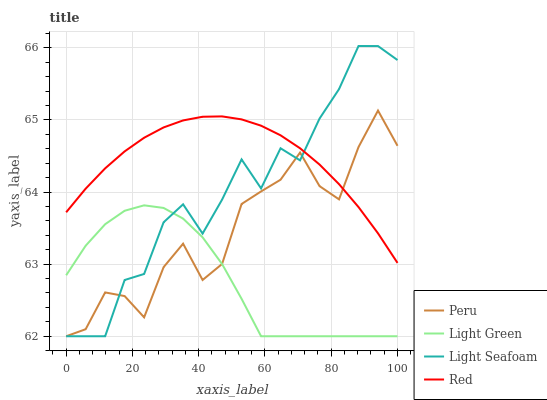Does Light Seafoam have the minimum area under the curve?
Answer yes or no. No. Does Light Seafoam have the maximum area under the curve?
Answer yes or no. No. Is Light Seafoam the smoothest?
Answer yes or no. No. Is Light Seafoam the roughest?
Answer yes or no. No. Does Light Green have the highest value?
Answer yes or no. No. Is Light Green less than Red?
Answer yes or no. Yes. Is Red greater than Light Green?
Answer yes or no. Yes. Does Light Green intersect Red?
Answer yes or no. No. 